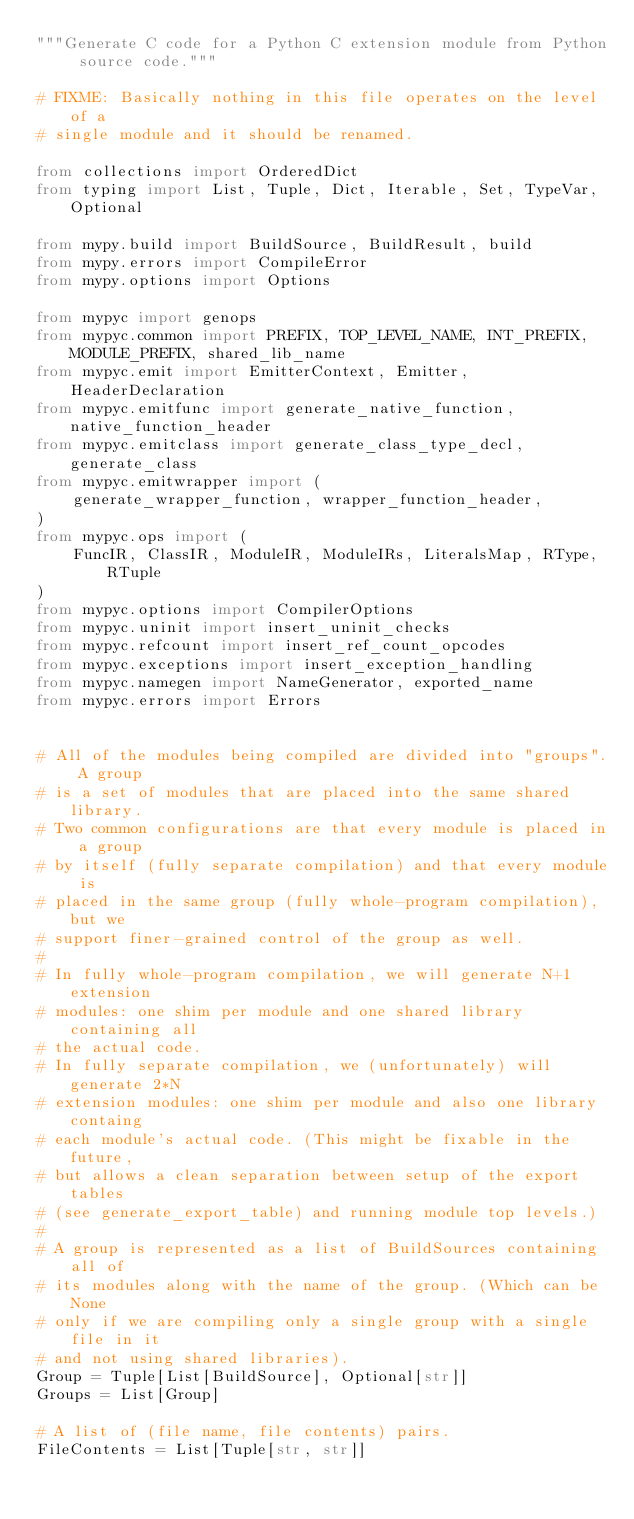<code> <loc_0><loc_0><loc_500><loc_500><_Python_>"""Generate C code for a Python C extension module from Python source code."""

# FIXME: Basically nothing in this file operates on the level of a
# single module and it should be renamed.

from collections import OrderedDict
from typing import List, Tuple, Dict, Iterable, Set, TypeVar, Optional

from mypy.build import BuildSource, BuildResult, build
from mypy.errors import CompileError
from mypy.options import Options

from mypyc import genops
from mypyc.common import PREFIX, TOP_LEVEL_NAME, INT_PREFIX, MODULE_PREFIX, shared_lib_name
from mypyc.emit import EmitterContext, Emitter, HeaderDeclaration
from mypyc.emitfunc import generate_native_function, native_function_header
from mypyc.emitclass import generate_class_type_decl, generate_class
from mypyc.emitwrapper import (
    generate_wrapper_function, wrapper_function_header,
)
from mypyc.ops import (
    FuncIR, ClassIR, ModuleIR, ModuleIRs, LiteralsMap, RType, RTuple
)
from mypyc.options import CompilerOptions
from mypyc.uninit import insert_uninit_checks
from mypyc.refcount import insert_ref_count_opcodes
from mypyc.exceptions import insert_exception_handling
from mypyc.namegen import NameGenerator, exported_name
from mypyc.errors import Errors


# All of the modules being compiled are divided into "groups". A group
# is a set of modules that are placed into the same shared library.
# Two common configurations are that every module is placed in a group
# by itself (fully separate compilation) and that every module is
# placed in the same group (fully whole-program compilation), but we
# support finer-grained control of the group as well.
#
# In fully whole-program compilation, we will generate N+1 extension
# modules: one shim per module and one shared library containing all
# the actual code.
# In fully separate compilation, we (unfortunately) will generate 2*N
# extension modules: one shim per module and also one library containg
# each module's actual code. (This might be fixable in the future,
# but allows a clean separation between setup of the export tables
# (see generate_export_table) and running module top levels.)
#
# A group is represented as a list of BuildSources containing all of
# its modules along with the name of the group. (Which can be None
# only if we are compiling only a single group with a single file in it
# and not using shared libraries).
Group = Tuple[List[BuildSource], Optional[str]]
Groups = List[Group]

# A list of (file name, file contents) pairs.
FileContents = List[Tuple[str, str]]

</code> 